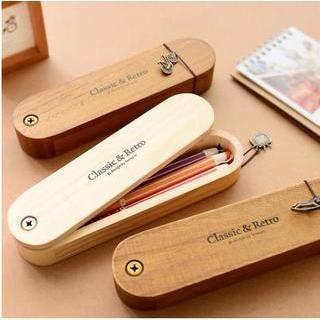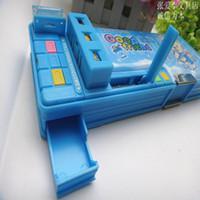The first image is the image on the left, the second image is the image on the right. Considering the images on both sides, is "At least one pencil case does not use a zipper to close." valid? Answer yes or no. Yes. 